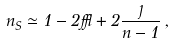<formula> <loc_0><loc_0><loc_500><loc_500>n _ { S } \simeq 1 - 2 \epsilon + 2 \frac { \eta } { n - 1 } \, ,</formula> 